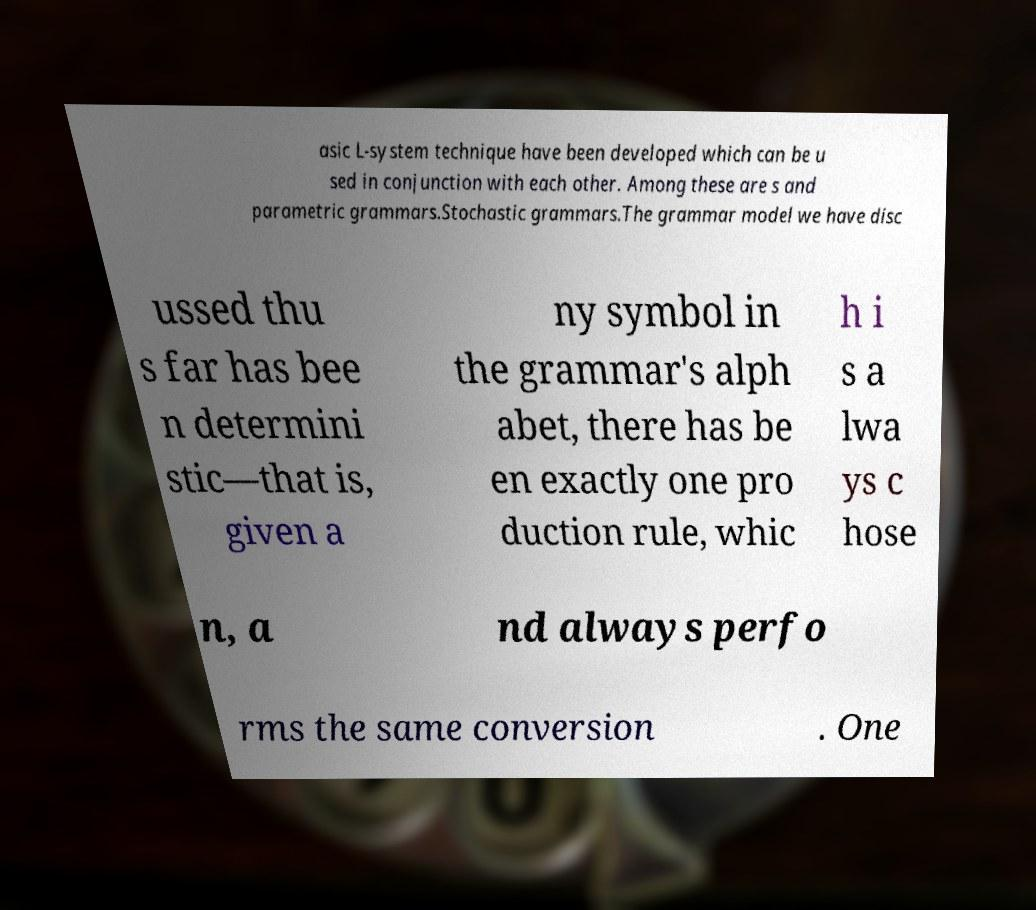There's text embedded in this image that I need extracted. Can you transcribe it verbatim? asic L-system technique have been developed which can be u sed in conjunction with each other. Among these are s and parametric grammars.Stochastic grammars.The grammar model we have disc ussed thu s far has bee n determini stic—that is, given a ny symbol in the grammar's alph abet, there has be en exactly one pro duction rule, whic h i s a lwa ys c hose n, a nd always perfo rms the same conversion . One 